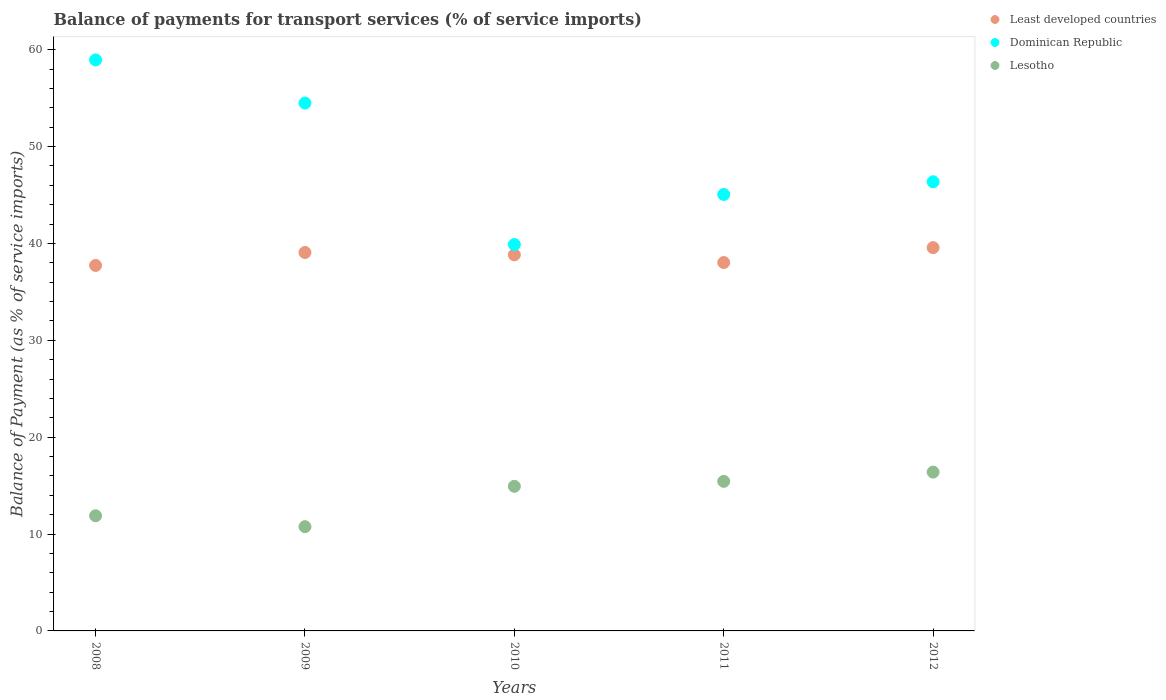How many different coloured dotlines are there?
Provide a succinct answer. 3. What is the balance of payments for transport services in Lesotho in 2009?
Give a very brief answer. 10.76. Across all years, what is the maximum balance of payments for transport services in Least developed countries?
Give a very brief answer. 39.57. Across all years, what is the minimum balance of payments for transport services in Lesotho?
Your answer should be very brief. 10.76. In which year was the balance of payments for transport services in Least developed countries minimum?
Your answer should be compact. 2008. What is the total balance of payments for transport services in Lesotho in the graph?
Provide a short and direct response. 69.42. What is the difference between the balance of payments for transport services in Dominican Republic in 2009 and that in 2011?
Give a very brief answer. 9.44. What is the difference between the balance of payments for transport services in Least developed countries in 2010 and the balance of payments for transport services in Dominican Republic in 2012?
Your answer should be compact. -7.54. What is the average balance of payments for transport services in Least developed countries per year?
Make the answer very short. 38.65. In the year 2010, what is the difference between the balance of payments for transport services in Lesotho and balance of payments for transport services in Dominican Republic?
Your answer should be compact. -24.96. What is the ratio of the balance of payments for transport services in Dominican Republic in 2008 to that in 2009?
Provide a short and direct response. 1.08. Is the balance of payments for transport services in Least developed countries in 2010 less than that in 2011?
Your answer should be compact. No. Is the difference between the balance of payments for transport services in Lesotho in 2008 and 2010 greater than the difference between the balance of payments for transport services in Dominican Republic in 2008 and 2010?
Your answer should be very brief. No. What is the difference between the highest and the second highest balance of payments for transport services in Least developed countries?
Give a very brief answer. 0.5. What is the difference between the highest and the lowest balance of payments for transport services in Least developed countries?
Offer a terse response. 1.84. In how many years, is the balance of payments for transport services in Least developed countries greater than the average balance of payments for transport services in Least developed countries taken over all years?
Make the answer very short. 3. Does the balance of payments for transport services in Lesotho monotonically increase over the years?
Provide a short and direct response. No. Is the balance of payments for transport services in Dominican Republic strictly greater than the balance of payments for transport services in Least developed countries over the years?
Keep it short and to the point. Yes. Is the balance of payments for transport services in Dominican Republic strictly less than the balance of payments for transport services in Least developed countries over the years?
Give a very brief answer. No. How many dotlines are there?
Provide a short and direct response. 3. Are the values on the major ticks of Y-axis written in scientific E-notation?
Offer a very short reply. No. Does the graph contain any zero values?
Your answer should be very brief. No. Does the graph contain grids?
Offer a terse response. No. Where does the legend appear in the graph?
Provide a succinct answer. Top right. How are the legend labels stacked?
Keep it short and to the point. Vertical. What is the title of the graph?
Offer a very short reply. Balance of payments for transport services (% of service imports). What is the label or title of the X-axis?
Ensure brevity in your answer.  Years. What is the label or title of the Y-axis?
Offer a terse response. Balance of Payment (as % of service imports). What is the Balance of Payment (as % of service imports) in Least developed countries in 2008?
Provide a succinct answer. 37.73. What is the Balance of Payment (as % of service imports) in Dominican Republic in 2008?
Keep it short and to the point. 58.95. What is the Balance of Payment (as % of service imports) of Lesotho in 2008?
Ensure brevity in your answer.  11.89. What is the Balance of Payment (as % of service imports) in Least developed countries in 2009?
Keep it short and to the point. 39.07. What is the Balance of Payment (as % of service imports) of Dominican Republic in 2009?
Provide a succinct answer. 54.5. What is the Balance of Payment (as % of service imports) of Lesotho in 2009?
Offer a terse response. 10.76. What is the Balance of Payment (as % of service imports) in Least developed countries in 2010?
Ensure brevity in your answer.  38.83. What is the Balance of Payment (as % of service imports) of Dominican Republic in 2010?
Your response must be concise. 39.89. What is the Balance of Payment (as % of service imports) in Lesotho in 2010?
Keep it short and to the point. 14.93. What is the Balance of Payment (as % of service imports) in Least developed countries in 2011?
Offer a very short reply. 38.03. What is the Balance of Payment (as % of service imports) of Dominican Republic in 2011?
Offer a terse response. 45.06. What is the Balance of Payment (as % of service imports) of Lesotho in 2011?
Offer a very short reply. 15.44. What is the Balance of Payment (as % of service imports) of Least developed countries in 2012?
Ensure brevity in your answer.  39.57. What is the Balance of Payment (as % of service imports) of Dominican Republic in 2012?
Provide a succinct answer. 46.37. What is the Balance of Payment (as % of service imports) of Lesotho in 2012?
Your response must be concise. 16.4. Across all years, what is the maximum Balance of Payment (as % of service imports) of Least developed countries?
Provide a succinct answer. 39.57. Across all years, what is the maximum Balance of Payment (as % of service imports) of Dominican Republic?
Your answer should be compact. 58.95. Across all years, what is the maximum Balance of Payment (as % of service imports) of Lesotho?
Give a very brief answer. 16.4. Across all years, what is the minimum Balance of Payment (as % of service imports) in Least developed countries?
Give a very brief answer. 37.73. Across all years, what is the minimum Balance of Payment (as % of service imports) in Dominican Republic?
Offer a terse response. 39.89. Across all years, what is the minimum Balance of Payment (as % of service imports) in Lesotho?
Provide a short and direct response. 10.76. What is the total Balance of Payment (as % of service imports) of Least developed countries in the graph?
Provide a short and direct response. 193.24. What is the total Balance of Payment (as % of service imports) in Dominican Republic in the graph?
Give a very brief answer. 244.78. What is the total Balance of Payment (as % of service imports) in Lesotho in the graph?
Your response must be concise. 69.42. What is the difference between the Balance of Payment (as % of service imports) of Least developed countries in 2008 and that in 2009?
Provide a short and direct response. -1.34. What is the difference between the Balance of Payment (as % of service imports) of Dominican Republic in 2008 and that in 2009?
Your response must be concise. 4.46. What is the difference between the Balance of Payment (as % of service imports) in Lesotho in 2008 and that in 2009?
Provide a succinct answer. 1.13. What is the difference between the Balance of Payment (as % of service imports) in Least developed countries in 2008 and that in 2010?
Make the answer very short. -1.1. What is the difference between the Balance of Payment (as % of service imports) of Dominican Republic in 2008 and that in 2010?
Ensure brevity in your answer.  19.06. What is the difference between the Balance of Payment (as % of service imports) in Lesotho in 2008 and that in 2010?
Provide a short and direct response. -3.04. What is the difference between the Balance of Payment (as % of service imports) in Least developed countries in 2008 and that in 2011?
Your answer should be very brief. -0.3. What is the difference between the Balance of Payment (as % of service imports) of Dominican Republic in 2008 and that in 2011?
Provide a short and direct response. 13.89. What is the difference between the Balance of Payment (as % of service imports) of Lesotho in 2008 and that in 2011?
Offer a very short reply. -3.55. What is the difference between the Balance of Payment (as % of service imports) in Least developed countries in 2008 and that in 2012?
Offer a terse response. -1.84. What is the difference between the Balance of Payment (as % of service imports) in Dominican Republic in 2008 and that in 2012?
Your response must be concise. 12.58. What is the difference between the Balance of Payment (as % of service imports) in Lesotho in 2008 and that in 2012?
Ensure brevity in your answer.  -4.51. What is the difference between the Balance of Payment (as % of service imports) in Least developed countries in 2009 and that in 2010?
Provide a succinct answer. 0.24. What is the difference between the Balance of Payment (as % of service imports) in Dominican Republic in 2009 and that in 2010?
Ensure brevity in your answer.  14.6. What is the difference between the Balance of Payment (as % of service imports) of Lesotho in 2009 and that in 2010?
Your answer should be very brief. -4.17. What is the difference between the Balance of Payment (as % of service imports) of Least developed countries in 2009 and that in 2011?
Keep it short and to the point. 1.04. What is the difference between the Balance of Payment (as % of service imports) in Dominican Republic in 2009 and that in 2011?
Keep it short and to the point. 9.44. What is the difference between the Balance of Payment (as % of service imports) of Lesotho in 2009 and that in 2011?
Offer a terse response. -4.68. What is the difference between the Balance of Payment (as % of service imports) in Least developed countries in 2009 and that in 2012?
Offer a very short reply. -0.5. What is the difference between the Balance of Payment (as % of service imports) of Dominican Republic in 2009 and that in 2012?
Your answer should be compact. 8.12. What is the difference between the Balance of Payment (as % of service imports) of Lesotho in 2009 and that in 2012?
Your response must be concise. -5.64. What is the difference between the Balance of Payment (as % of service imports) in Least developed countries in 2010 and that in 2011?
Offer a terse response. 0.8. What is the difference between the Balance of Payment (as % of service imports) in Dominican Republic in 2010 and that in 2011?
Keep it short and to the point. -5.17. What is the difference between the Balance of Payment (as % of service imports) of Lesotho in 2010 and that in 2011?
Your response must be concise. -0.51. What is the difference between the Balance of Payment (as % of service imports) of Least developed countries in 2010 and that in 2012?
Give a very brief answer. -0.74. What is the difference between the Balance of Payment (as % of service imports) in Dominican Republic in 2010 and that in 2012?
Provide a short and direct response. -6.48. What is the difference between the Balance of Payment (as % of service imports) in Lesotho in 2010 and that in 2012?
Offer a very short reply. -1.47. What is the difference between the Balance of Payment (as % of service imports) in Least developed countries in 2011 and that in 2012?
Your response must be concise. -1.54. What is the difference between the Balance of Payment (as % of service imports) of Dominican Republic in 2011 and that in 2012?
Offer a terse response. -1.31. What is the difference between the Balance of Payment (as % of service imports) of Lesotho in 2011 and that in 2012?
Your answer should be very brief. -0.96. What is the difference between the Balance of Payment (as % of service imports) in Least developed countries in 2008 and the Balance of Payment (as % of service imports) in Dominican Republic in 2009?
Your answer should be compact. -16.76. What is the difference between the Balance of Payment (as % of service imports) of Least developed countries in 2008 and the Balance of Payment (as % of service imports) of Lesotho in 2009?
Give a very brief answer. 26.97. What is the difference between the Balance of Payment (as % of service imports) of Dominican Republic in 2008 and the Balance of Payment (as % of service imports) of Lesotho in 2009?
Keep it short and to the point. 48.19. What is the difference between the Balance of Payment (as % of service imports) of Least developed countries in 2008 and the Balance of Payment (as % of service imports) of Dominican Republic in 2010?
Provide a short and direct response. -2.16. What is the difference between the Balance of Payment (as % of service imports) of Least developed countries in 2008 and the Balance of Payment (as % of service imports) of Lesotho in 2010?
Offer a terse response. 22.8. What is the difference between the Balance of Payment (as % of service imports) in Dominican Republic in 2008 and the Balance of Payment (as % of service imports) in Lesotho in 2010?
Provide a succinct answer. 44.02. What is the difference between the Balance of Payment (as % of service imports) in Least developed countries in 2008 and the Balance of Payment (as % of service imports) in Dominican Republic in 2011?
Offer a terse response. -7.33. What is the difference between the Balance of Payment (as % of service imports) of Least developed countries in 2008 and the Balance of Payment (as % of service imports) of Lesotho in 2011?
Your answer should be very brief. 22.29. What is the difference between the Balance of Payment (as % of service imports) in Dominican Republic in 2008 and the Balance of Payment (as % of service imports) in Lesotho in 2011?
Offer a very short reply. 43.51. What is the difference between the Balance of Payment (as % of service imports) in Least developed countries in 2008 and the Balance of Payment (as % of service imports) in Dominican Republic in 2012?
Your answer should be compact. -8.64. What is the difference between the Balance of Payment (as % of service imports) in Least developed countries in 2008 and the Balance of Payment (as % of service imports) in Lesotho in 2012?
Provide a short and direct response. 21.33. What is the difference between the Balance of Payment (as % of service imports) in Dominican Republic in 2008 and the Balance of Payment (as % of service imports) in Lesotho in 2012?
Your answer should be very brief. 42.56. What is the difference between the Balance of Payment (as % of service imports) of Least developed countries in 2009 and the Balance of Payment (as % of service imports) of Dominican Republic in 2010?
Ensure brevity in your answer.  -0.82. What is the difference between the Balance of Payment (as % of service imports) of Least developed countries in 2009 and the Balance of Payment (as % of service imports) of Lesotho in 2010?
Give a very brief answer. 24.14. What is the difference between the Balance of Payment (as % of service imports) of Dominican Republic in 2009 and the Balance of Payment (as % of service imports) of Lesotho in 2010?
Keep it short and to the point. 39.57. What is the difference between the Balance of Payment (as % of service imports) of Least developed countries in 2009 and the Balance of Payment (as % of service imports) of Dominican Republic in 2011?
Make the answer very short. -5.99. What is the difference between the Balance of Payment (as % of service imports) in Least developed countries in 2009 and the Balance of Payment (as % of service imports) in Lesotho in 2011?
Make the answer very short. 23.63. What is the difference between the Balance of Payment (as % of service imports) in Dominican Republic in 2009 and the Balance of Payment (as % of service imports) in Lesotho in 2011?
Ensure brevity in your answer.  39.05. What is the difference between the Balance of Payment (as % of service imports) in Least developed countries in 2009 and the Balance of Payment (as % of service imports) in Dominican Republic in 2012?
Keep it short and to the point. -7.3. What is the difference between the Balance of Payment (as % of service imports) in Least developed countries in 2009 and the Balance of Payment (as % of service imports) in Lesotho in 2012?
Ensure brevity in your answer.  22.67. What is the difference between the Balance of Payment (as % of service imports) in Dominican Republic in 2009 and the Balance of Payment (as % of service imports) in Lesotho in 2012?
Your response must be concise. 38.1. What is the difference between the Balance of Payment (as % of service imports) in Least developed countries in 2010 and the Balance of Payment (as % of service imports) in Dominican Republic in 2011?
Your answer should be very brief. -6.23. What is the difference between the Balance of Payment (as % of service imports) in Least developed countries in 2010 and the Balance of Payment (as % of service imports) in Lesotho in 2011?
Offer a terse response. 23.39. What is the difference between the Balance of Payment (as % of service imports) of Dominican Republic in 2010 and the Balance of Payment (as % of service imports) of Lesotho in 2011?
Make the answer very short. 24.45. What is the difference between the Balance of Payment (as % of service imports) of Least developed countries in 2010 and the Balance of Payment (as % of service imports) of Dominican Republic in 2012?
Provide a succinct answer. -7.54. What is the difference between the Balance of Payment (as % of service imports) in Least developed countries in 2010 and the Balance of Payment (as % of service imports) in Lesotho in 2012?
Offer a terse response. 22.43. What is the difference between the Balance of Payment (as % of service imports) of Dominican Republic in 2010 and the Balance of Payment (as % of service imports) of Lesotho in 2012?
Keep it short and to the point. 23.5. What is the difference between the Balance of Payment (as % of service imports) of Least developed countries in 2011 and the Balance of Payment (as % of service imports) of Dominican Republic in 2012?
Your answer should be compact. -8.34. What is the difference between the Balance of Payment (as % of service imports) in Least developed countries in 2011 and the Balance of Payment (as % of service imports) in Lesotho in 2012?
Your answer should be compact. 21.64. What is the difference between the Balance of Payment (as % of service imports) of Dominican Republic in 2011 and the Balance of Payment (as % of service imports) of Lesotho in 2012?
Keep it short and to the point. 28.66. What is the average Balance of Payment (as % of service imports) of Least developed countries per year?
Make the answer very short. 38.65. What is the average Balance of Payment (as % of service imports) in Dominican Republic per year?
Provide a short and direct response. 48.96. What is the average Balance of Payment (as % of service imports) in Lesotho per year?
Offer a terse response. 13.88. In the year 2008, what is the difference between the Balance of Payment (as % of service imports) in Least developed countries and Balance of Payment (as % of service imports) in Dominican Republic?
Give a very brief answer. -21.22. In the year 2008, what is the difference between the Balance of Payment (as % of service imports) of Least developed countries and Balance of Payment (as % of service imports) of Lesotho?
Give a very brief answer. 25.84. In the year 2008, what is the difference between the Balance of Payment (as % of service imports) in Dominican Republic and Balance of Payment (as % of service imports) in Lesotho?
Give a very brief answer. 47.06. In the year 2009, what is the difference between the Balance of Payment (as % of service imports) in Least developed countries and Balance of Payment (as % of service imports) in Dominican Republic?
Your answer should be compact. -15.43. In the year 2009, what is the difference between the Balance of Payment (as % of service imports) in Least developed countries and Balance of Payment (as % of service imports) in Lesotho?
Provide a succinct answer. 28.31. In the year 2009, what is the difference between the Balance of Payment (as % of service imports) of Dominican Republic and Balance of Payment (as % of service imports) of Lesotho?
Your response must be concise. 43.74. In the year 2010, what is the difference between the Balance of Payment (as % of service imports) in Least developed countries and Balance of Payment (as % of service imports) in Dominican Republic?
Keep it short and to the point. -1.06. In the year 2010, what is the difference between the Balance of Payment (as % of service imports) in Least developed countries and Balance of Payment (as % of service imports) in Lesotho?
Provide a short and direct response. 23.9. In the year 2010, what is the difference between the Balance of Payment (as % of service imports) of Dominican Republic and Balance of Payment (as % of service imports) of Lesotho?
Offer a terse response. 24.96. In the year 2011, what is the difference between the Balance of Payment (as % of service imports) in Least developed countries and Balance of Payment (as % of service imports) in Dominican Republic?
Provide a succinct answer. -7.03. In the year 2011, what is the difference between the Balance of Payment (as % of service imports) of Least developed countries and Balance of Payment (as % of service imports) of Lesotho?
Offer a very short reply. 22.59. In the year 2011, what is the difference between the Balance of Payment (as % of service imports) in Dominican Republic and Balance of Payment (as % of service imports) in Lesotho?
Your answer should be very brief. 29.62. In the year 2012, what is the difference between the Balance of Payment (as % of service imports) of Least developed countries and Balance of Payment (as % of service imports) of Dominican Republic?
Ensure brevity in your answer.  -6.8. In the year 2012, what is the difference between the Balance of Payment (as % of service imports) in Least developed countries and Balance of Payment (as % of service imports) in Lesotho?
Offer a terse response. 23.17. In the year 2012, what is the difference between the Balance of Payment (as % of service imports) in Dominican Republic and Balance of Payment (as % of service imports) in Lesotho?
Your answer should be compact. 29.98. What is the ratio of the Balance of Payment (as % of service imports) in Least developed countries in 2008 to that in 2009?
Your response must be concise. 0.97. What is the ratio of the Balance of Payment (as % of service imports) in Dominican Republic in 2008 to that in 2009?
Give a very brief answer. 1.08. What is the ratio of the Balance of Payment (as % of service imports) in Lesotho in 2008 to that in 2009?
Give a very brief answer. 1.1. What is the ratio of the Balance of Payment (as % of service imports) of Least developed countries in 2008 to that in 2010?
Provide a succinct answer. 0.97. What is the ratio of the Balance of Payment (as % of service imports) in Dominican Republic in 2008 to that in 2010?
Offer a very short reply. 1.48. What is the ratio of the Balance of Payment (as % of service imports) in Lesotho in 2008 to that in 2010?
Provide a short and direct response. 0.8. What is the ratio of the Balance of Payment (as % of service imports) in Dominican Republic in 2008 to that in 2011?
Offer a terse response. 1.31. What is the ratio of the Balance of Payment (as % of service imports) of Lesotho in 2008 to that in 2011?
Keep it short and to the point. 0.77. What is the ratio of the Balance of Payment (as % of service imports) of Least developed countries in 2008 to that in 2012?
Your answer should be very brief. 0.95. What is the ratio of the Balance of Payment (as % of service imports) of Dominican Republic in 2008 to that in 2012?
Offer a very short reply. 1.27. What is the ratio of the Balance of Payment (as % of service imports) in Lesotho in 2008 to that in 2012?
Give a very brief answer. 0.72. What is the ratio of the Balance of Payment (as % of service imports) in Least developed countries in 2009 to that in 2010?
Keep it short and to the point. 1.01. What is the ratio of the Balance of Payment (as % of service imports) of Dominican Republic in 2009 to that in 2010?
Ensure brevity in your answer.  1.37. What is the ratio of the Balance of Payment (as % of service imports) of Lesotho in 2009 to that in 2010?
Provide a short and direct response. 0.72. What is the ratio of the Balance of Payment (as % of service imports) of Least developed countries in 2009 to that in 2011?
Offer a very short reply. 1.03. What is the ratio of the Balance of Payment (as % of service imports) in Dominican Republic in 2009 to that in 2011?
Your answer should be very brief. 1.21. What is the ratio of the Balance of Payment (as % of service imports) in Lesotho in 2009 to that in 2011?
Your answer should be very brief. 0.7. What is the ratio of the Balance of Payment (as % of service imports) in Least developed countries in 2009 to that in 2012?
Your response must be concise. 0.99. What is the ratio of the Balance of Payment (as % of service imports) in Dominican Republic in 2009 to that in 2012?
Your response must be concise. 1.18. What is the ratio of the Balance of Payment (as % of service imports) of Lesotho in 2009 to that in 2012?
Your response must be concise. 0.66. What is the ratio of the Balance of Payment (as % of service imports) in Least developed countries in 2010 to that in 2011?
Give a very brief answer. 1.02. What is the ratio of the Balance of Payment (as % of service imports) of Dominican Republic in 2010 to that in 2011?
Offer a terse response. 0.89. What is the ratio of the Balance of Payment (as % of service imports) in Lesotho in 2010 to that in 2011?
Provide a succinct answer. 0.97. What is the ratio of the Balance of Payment (as % of service imports) of Least developed countries in 2010 to that in 2012?
Keep it short and to the point. 0.98. What is the ratio of the Balance of Payment (as % of service imports) in Dominican Republic in 2010 to that in 2012?
Offer a very short reply. 0.86. What is the ratio of the Balance of Payment (as % of service imports) in Lesotho in 2010 to that in 2012?
Give a very brief answer. 0.91. What is the ratio of the Balance of Payment (as % of service imports) in Least developed countries in 2011 to that in 2012?
Your answer should be very brief. 0.96. What is the ratio of the Balance of Payment (as % of service imports) of Dominican Republic in 2011 to that in 2012?
Your answer should be compact. 0.97. What is the ratio of the Balance of Payment (as % of service imports) of Lesotho in 2011 to that in 2012?
Give a very brief answer. 0.94. What is the difference between the highest and the second highest Balance of Payment (as % of service imports) of Least developed countries?
Give a very brief answer. 0.5. What is the difference between the highest and the second highest Balance of Payment (as % of service imports) of Dominican Republic?
Your response must be concise. 4.46. What is the difference between the highest and the second highest Balance of Payment (as % of service imports) in Lesotho?
Ensure brevity in your answer.  0.96. What is the difference between the highest and the lowest Balance of Payment (as % of service imports) of Least developed countries?
Keep it short and to the point. 1.84. What is the difference between the highest and the lowest Balance of Payment (as % of service imports) of Dominican Republic?
Your answer should be very brief. 19.06. What is the difference between the highest and the lowest Balance of Payment (as % of service imports) of Lesotho?
Your response must be concise. 5.64. 